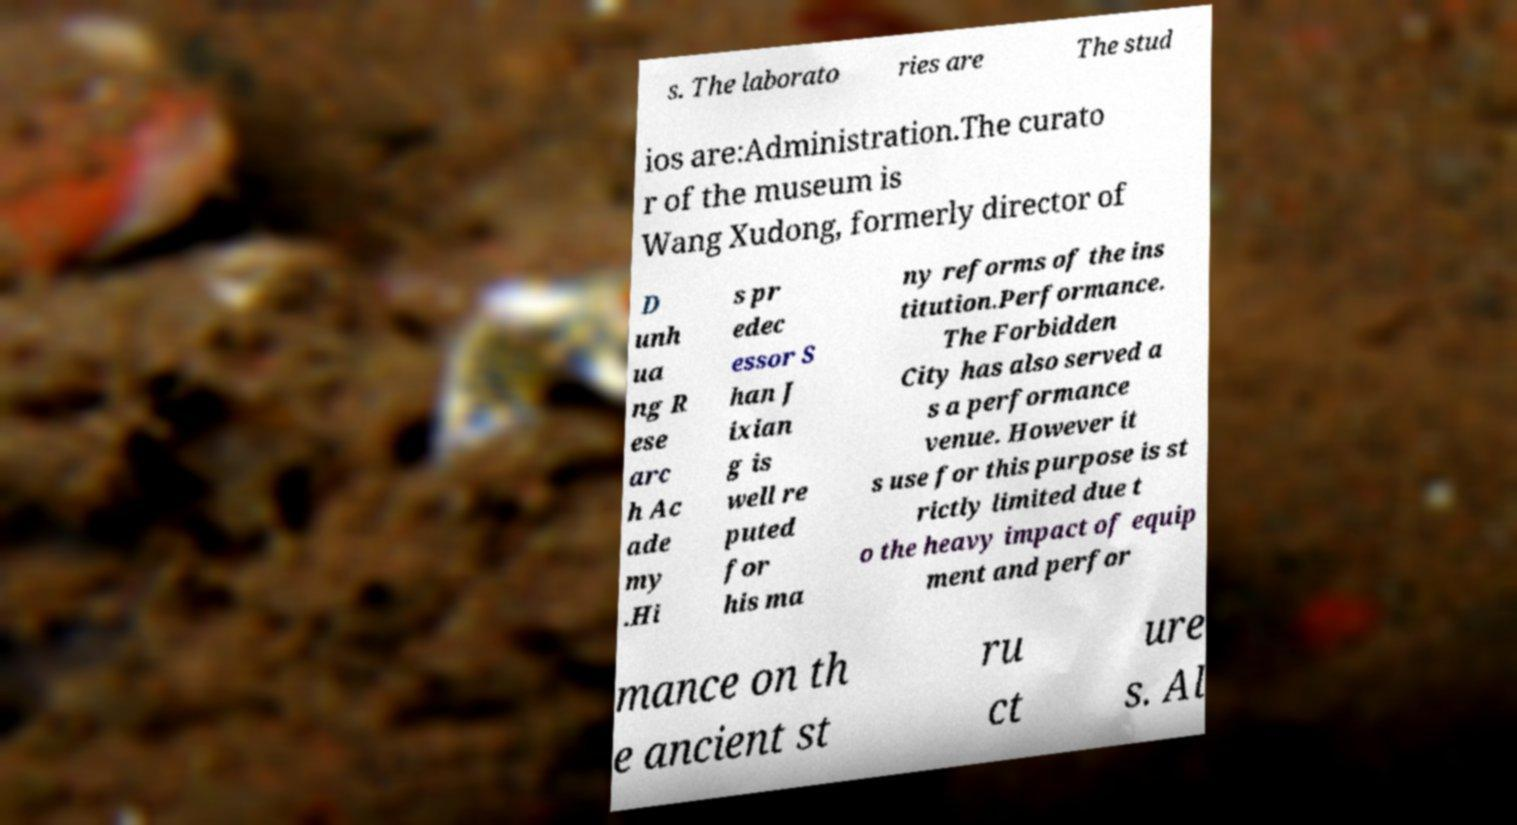Can you read and provide the text displayed in the image?This photo seems to have some interesting text. Can you extract and type it out for me? s. The laborato ries are The stud ios are:Administration.The curato r of the museum is Wang Xudong, formerly director of D unh ua ng R ese arc h Ac ade my .Hi s pr edec essor S han J ixian g is well re puted for his ma ny reforms of the ins titution.Performance. The Forbidden City has also served a s a performance venue. However it s use for this purpose is st rictly limited due t o the heavy impact of equip ment and perfor mance on th e ancient st ru ct ure s. Al 